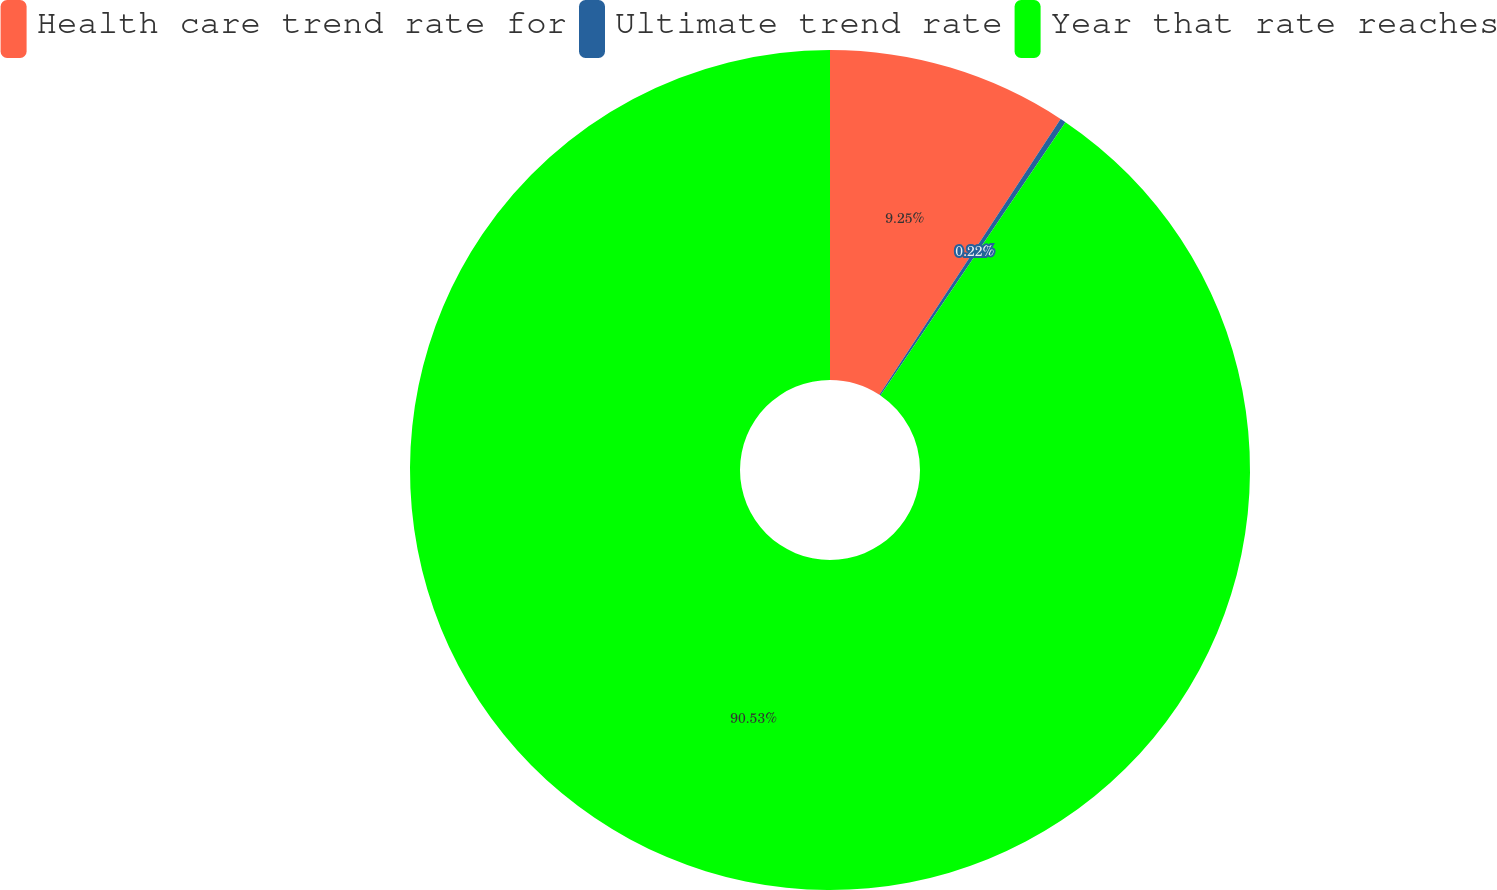<chart> <loc_0><loc_0><loc_500><loc_500><pie_chart><fcel>Health care trend rate for<fcel>Ultimate trend rate<fcel>Year that rate reaches<nl><fcel>9.25%<fcel>0.22%<fcel>90.52%<nl></chart> 